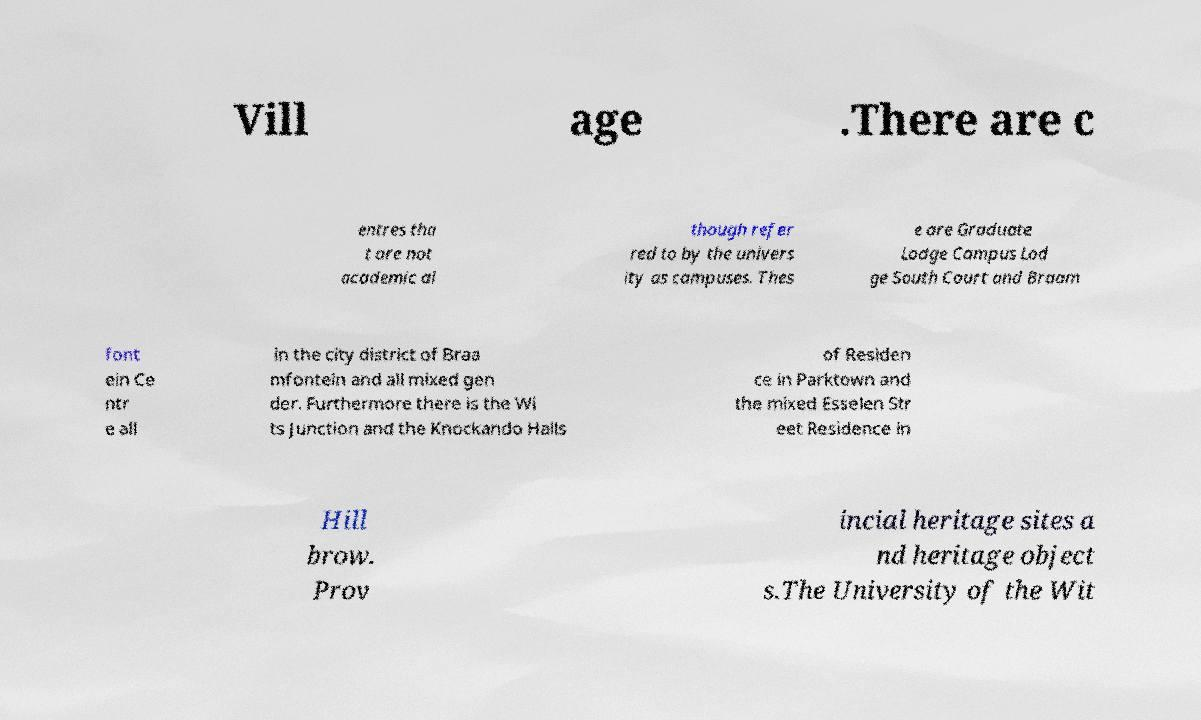Could you extract and type out the text from this image? Vill age .There are c entres tha t are not academic al though refer red to by the univers ity as campuses. Thes e are Graduate Lodge Campus Lod ge South Court and Braam font ein Ce ntr e all in the city district of Braa mfontein and all mixed gen der. Furthermore there is the Wi ts Junction and the Knockando Halls of Residen ce in Parktown and the mixed Esselen Str eet Residence in Hill brow. Prov incial heritage sites a nd heritage object s.The University of the Wit 